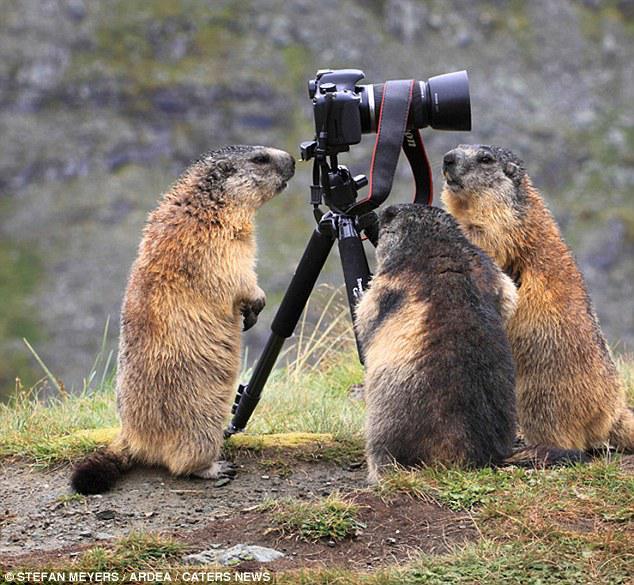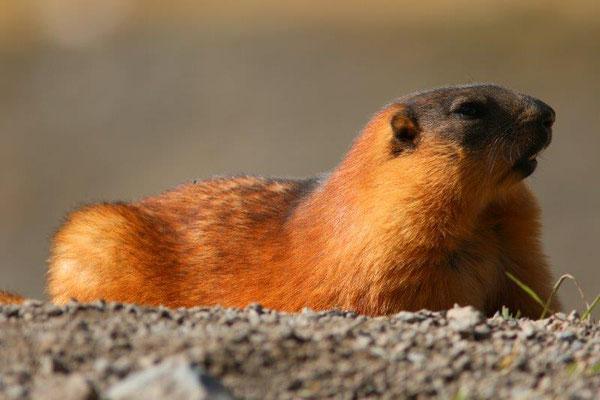The first image is the image on the left, the second image is the image on the right. For the images shown, is this caption "There are our groundhogs." true? Answer yes or no. Yes. The first image is the image on the left, the second image is the image on the right. Considering the images on both sides, is "One image shows at least two marmots standing up and facing towards each other, with their front paws hanging down." valid? Answer yes or no. Yes. 